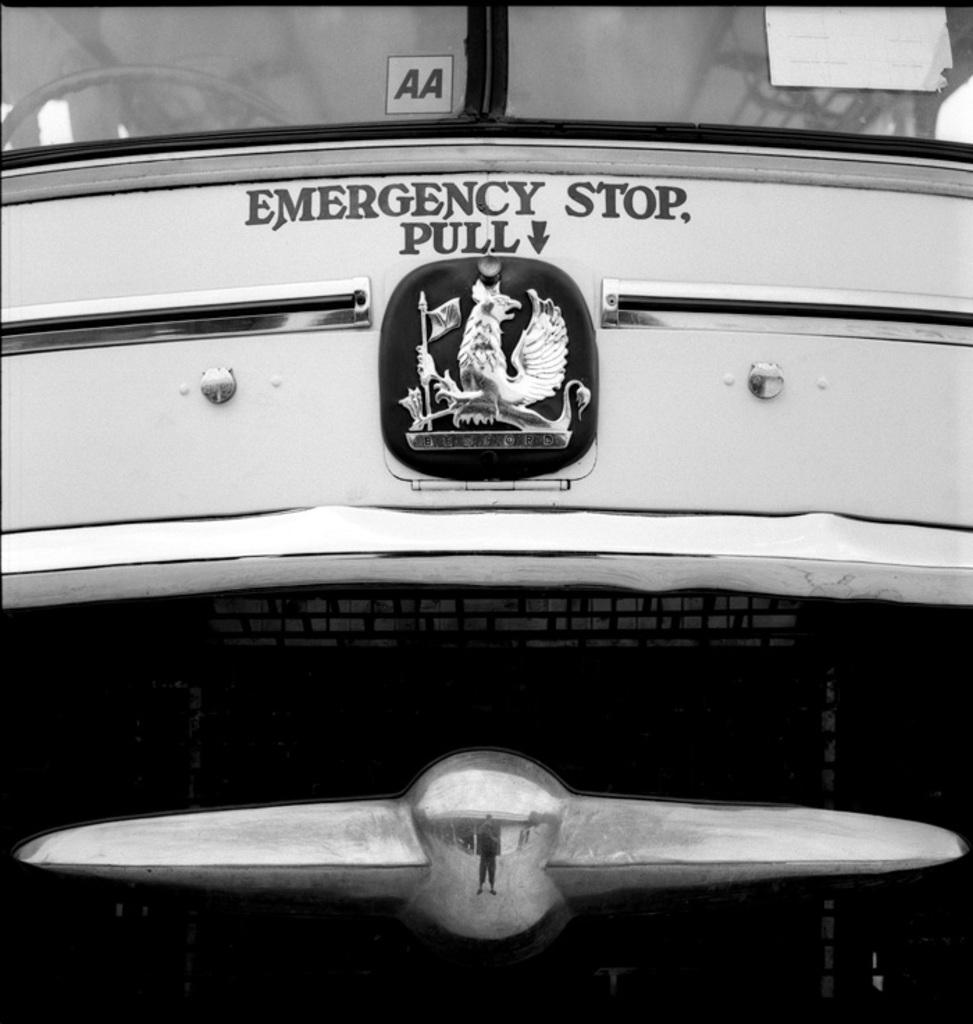Provide a one-sentence caption for the provided image. the front of a vehicle with a sign for an emergency stop pull. 